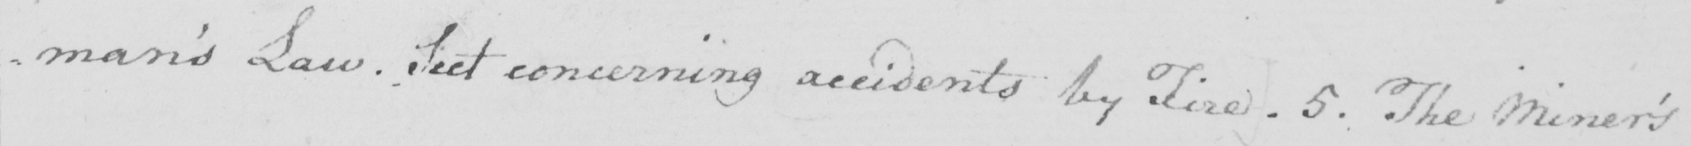Transcribe the text shown in this historical manuscript line. man ' s Law . Sect concerning accidents by Fire . 5 . The Miner ' s 